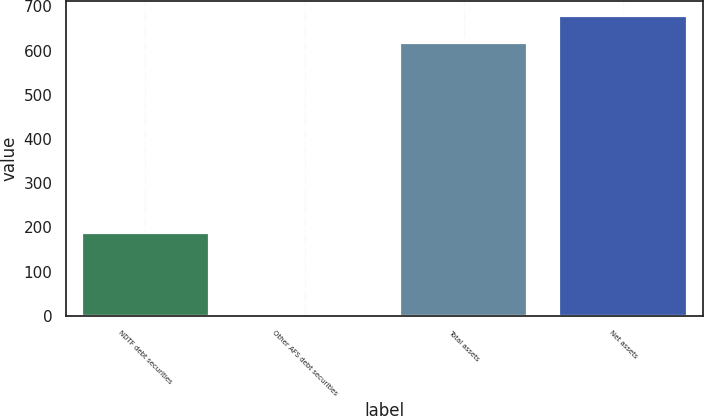Convert chart. <chart><loc_0><loc_0><loc_500><loc_500><bar_chart><fcel>NDTF debt securities<fcel>Other AFS debt securities<fcel>Total assets<fcel>Net assets<nl><fcel>188<fcel>1<fcel>616<fcel>677.5<nl></chart> 